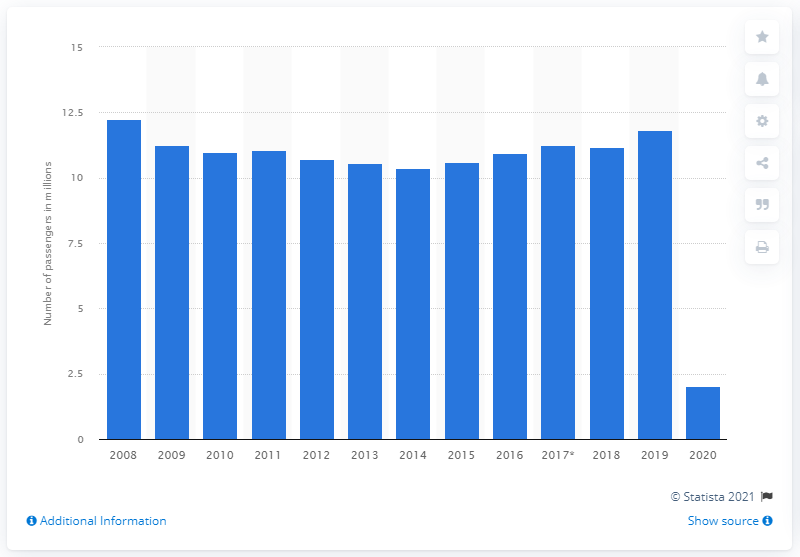Indicate a few pertinent items in this graphic. During the period of 2008 to 2014, TUI Airways Ltd carried a total of 10,370 passengers. In 2008, TUI Airways Ltd experienced a peak in passenger numbers. Specifically, the company reported that the number of passengers it transported was 12,230. In 2019, the number of passengers was 11.82. 